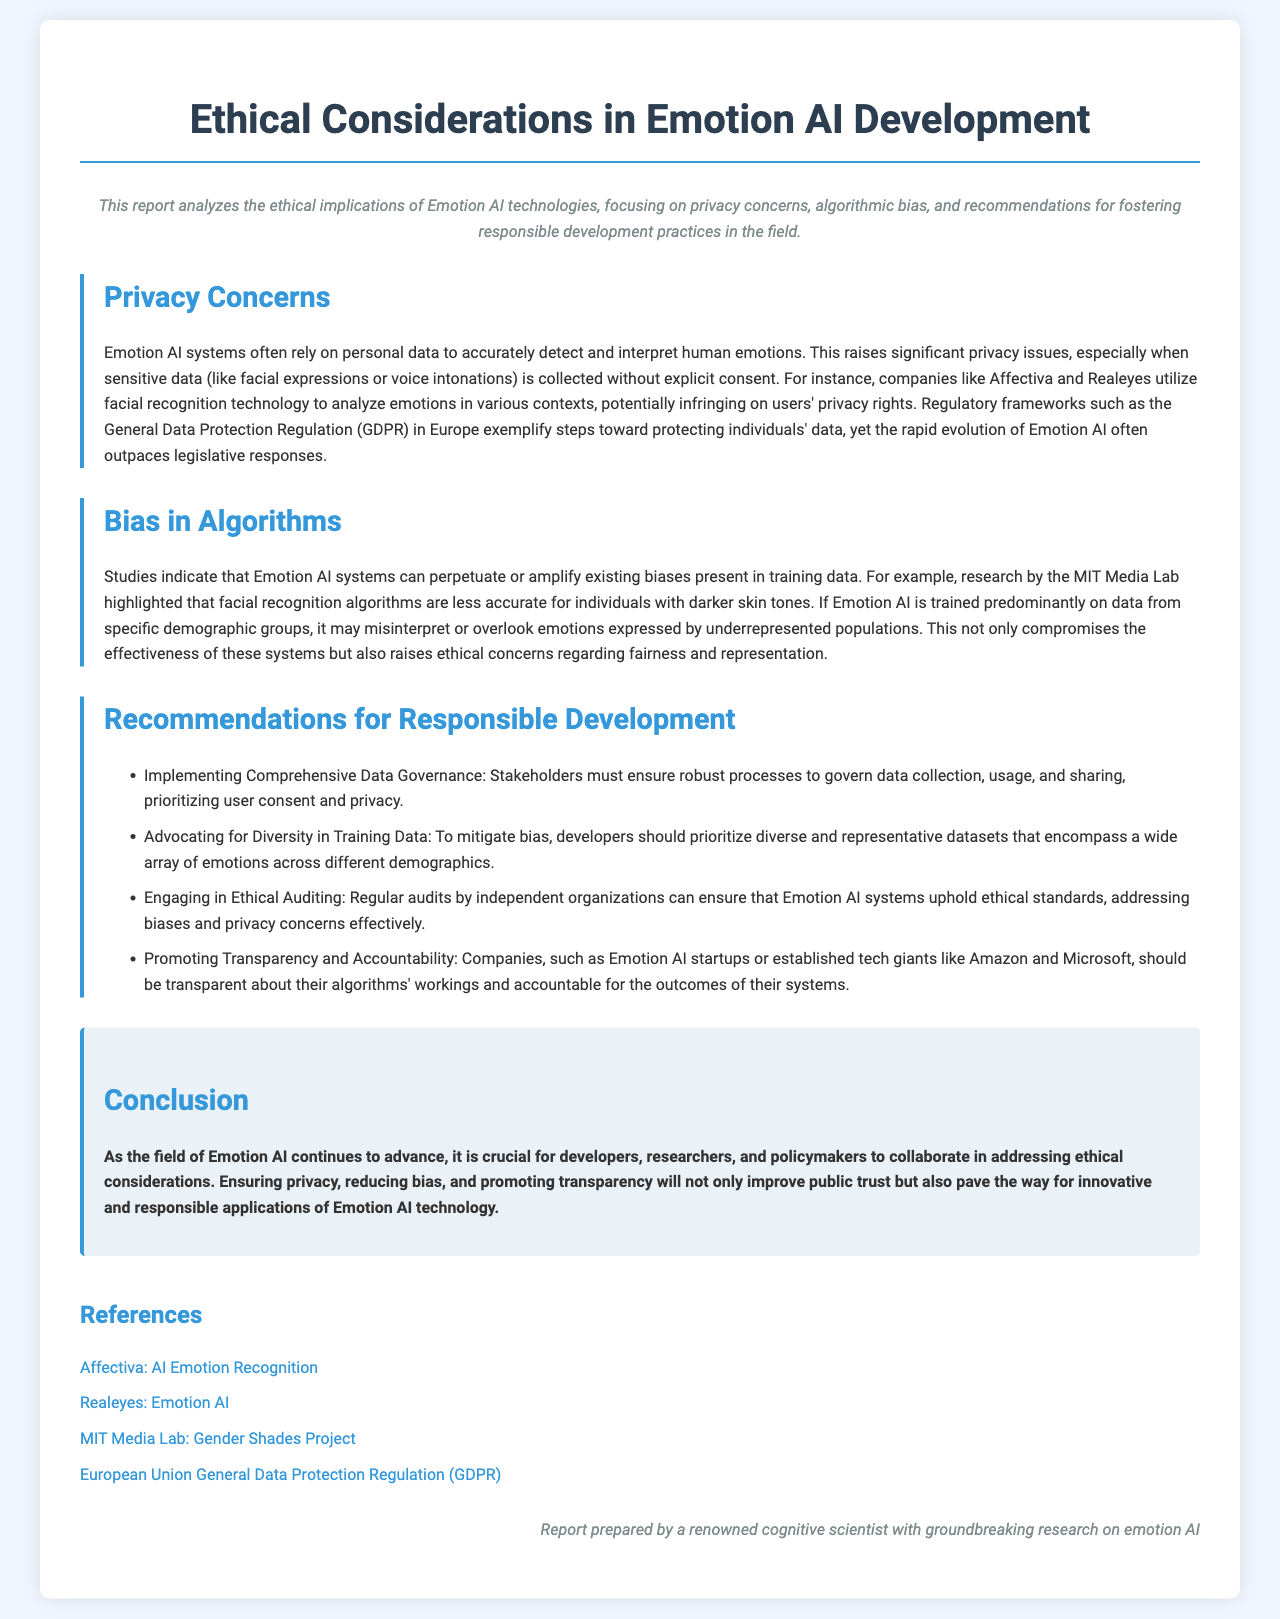What is the title of the report? The title of the report is the main heading displayed at the top of the document.
Answer: Ethical Considerations in Emotion AI Development What are the four recommendations for responsible development? The recommendations are presented in a list format in the document and focus on specific actions to promote ethical practices.
Answer: 1. Implementing Comprehensive Data Governance 2. Advocating for Diversity in Training Data 3. Engaging in Ethical Auditing 4. Promoting Transparency and Accountability Which regulation is mentioned as a step toward protecting individuals' data? The document mentions the regulation as an example of legislative action regarding data privacy in Emotion AI contexts.
Answer: General Data Protection Regulation (GDPR) What organization is highlighted for its research on facial recognition and bias? The document refers to an organization that conducted studies on bias in algorithms related to facial recognition technologies.
Answer: MIT Media Lab What is the main concern regarding the use of personal data in Emotion AI? The document discusses issues related to privacy that arise from the collection and usage of sensitive data in Emotion AI systems.
Answer: Privacy concerns Which companies are mentioned that utilize facial recognition technology? The report names specific companies in the context of analyzing emotions through facial recognition technology.
Answer: Affectiva and Realeyes What is emphasized as crucial for developers, researchers, and policymakers? The document outlines a shared responsibility among key stakeholders in the field of Emotion AI.
Answer: Collaboration in addressing ethical considerations 